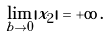Convert formula to latex. <formula><loc_0><loc_0><loc_500><loc_500>\lim _ { b \to 0 } | x _ { 2 } | = + \infty \, .</formula> 